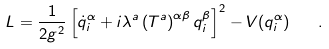<formula> <loc_0><loc_0><loc_500><loc_500>L = \frac { 1 } { 2 g ^ { 2 } } \left [ \dot { q } _ { i } ^ { \alpha } + i \lambda ^ { a } \left ( T ^ { a } \right ) ^ { \alpha \beta } q _ { i } ^ { \beta } \right ] ^ { 2 } - V ( q _ { i } ^ { \alpha } ) \quad .</formula> 